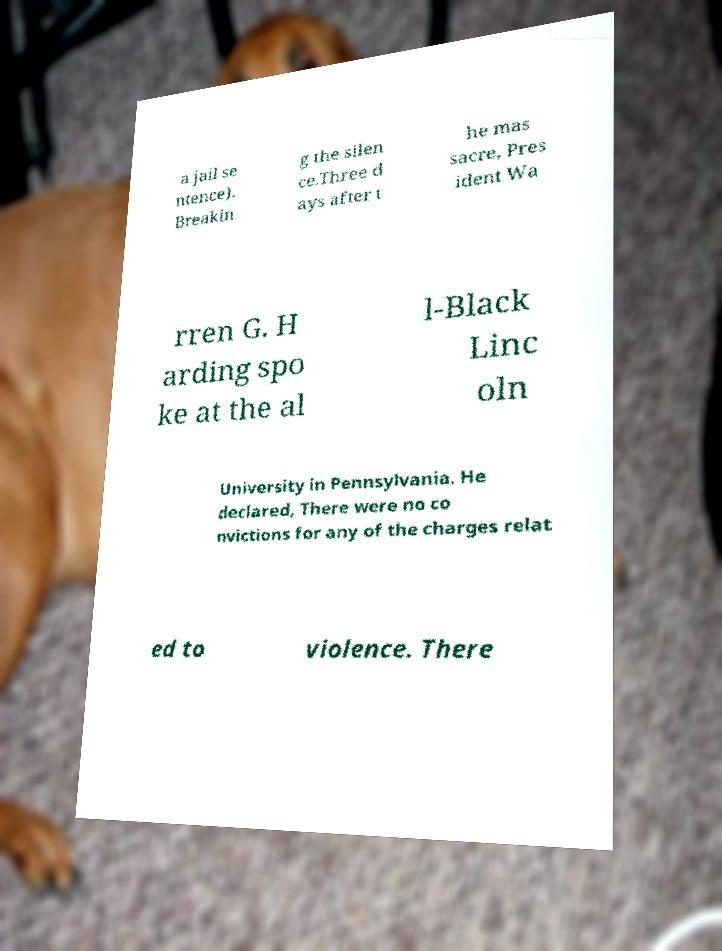I need the written content from this picture converted into text. Can you do that? a jail se ntence). Breakin g the silen ce.Three d ays after t he mas sacre, Pres ident Wa rren G. H arding spo ke at the al l-Black Linc oln University in Pennsylvania. He declared, There were no co nvictions for any of the charges relat ed to violence. There 